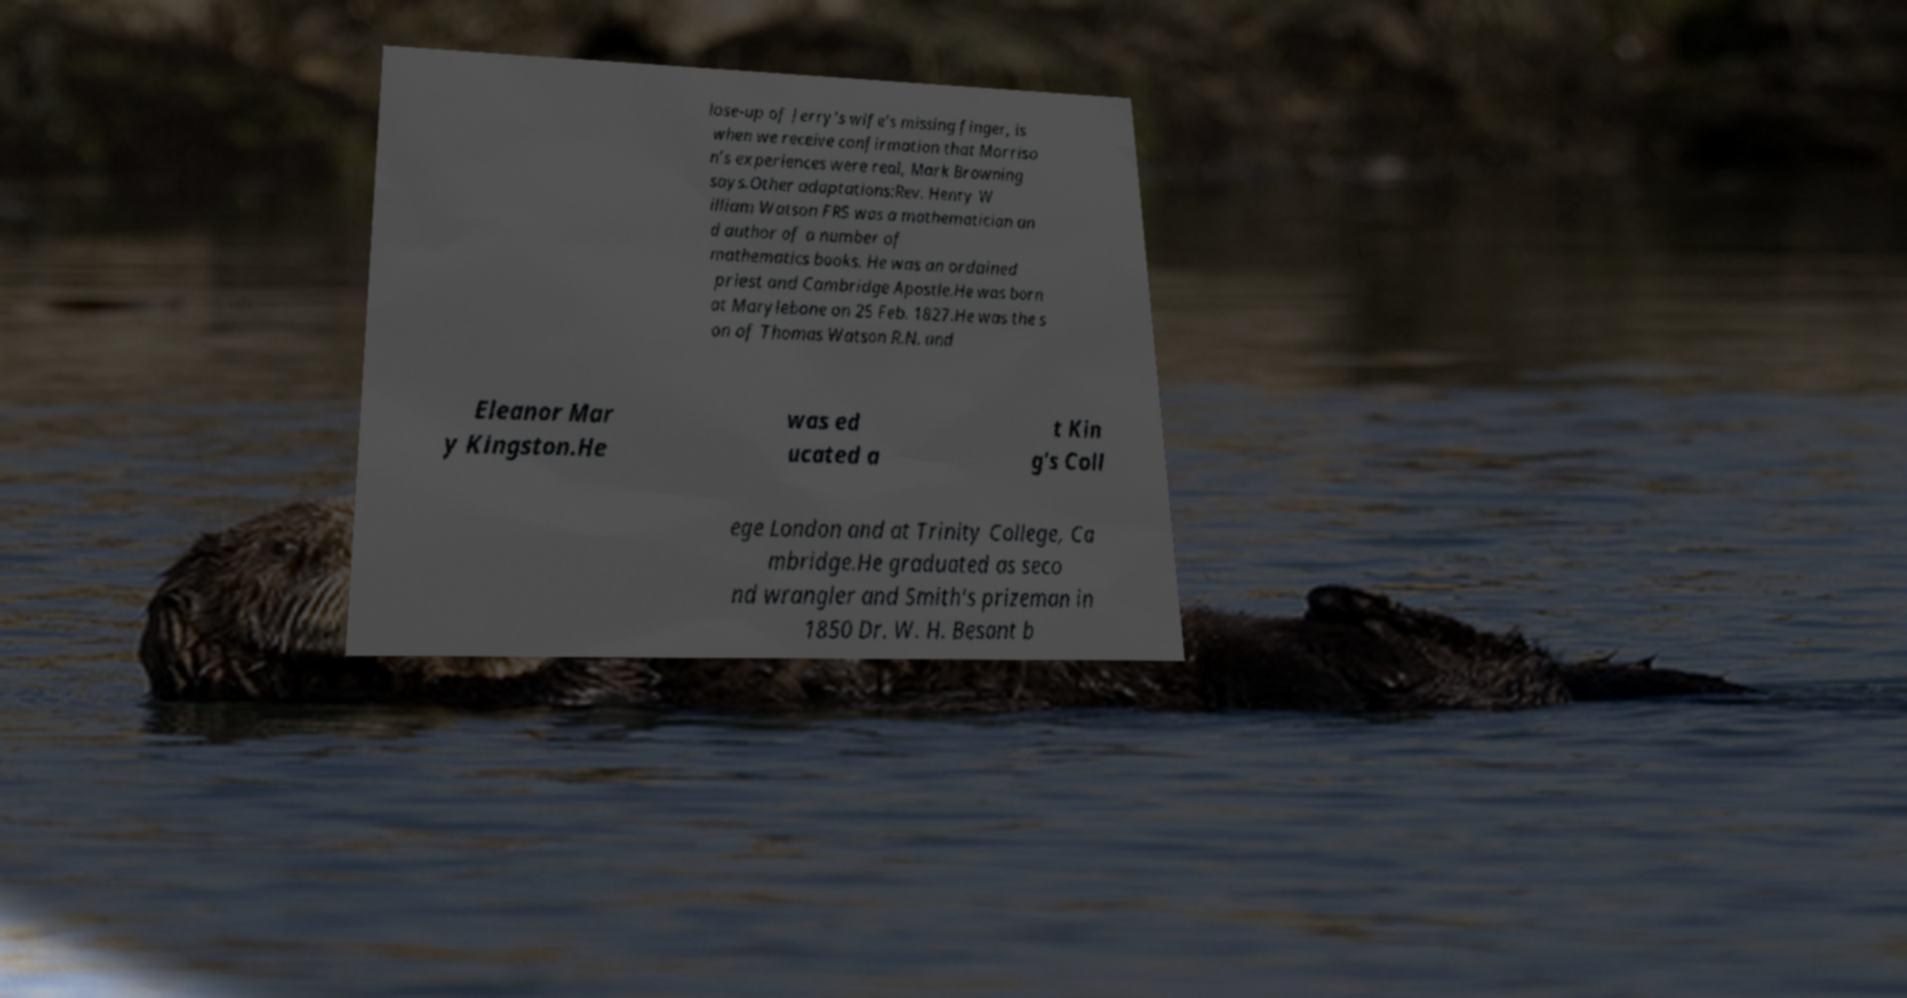Can you read and provide the text displayed in the image?This photo seems to have some interesting text. Can you extract and type it out for me? lose-up of Jerry’s wife’s missing finger, is when we receive confirmation that Morriso n’s experiences were real, Mark Browning says.Other adaptations:Rev. Henry W illiam Watson FRS was a mathematician an d author of a number of mathematics books. He was an ordained priest and Cambridge Apostle.He was born at Marylebone on 25 Feb. 1827.He was the s on of Thomas Watson R.N. and Eleanor Mar y Kingston.He was ed ucated a t Kin g's Coll ege London and at Trinity College, Ca mbridge.He graduated as seco nd wrangler and Smith's prizeman in 1850 Dr. W. H. Besant b 